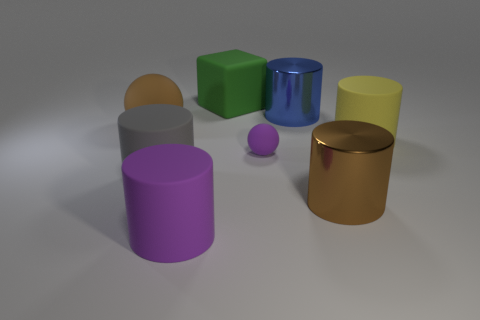Is there any other thing that is the same shape as the big green matte thing?
Ensure brevity in your answer.  No. How many big yellow cylinders are the same material as the green thing?
Your answer should be compact. 1. There is a block that is the same material as the large sphere; what is its color?
Keep it short and to the point. Green. Does the big gray matte thing have the same shape as the large blue thing?
Your response must be concise. Yes. There is a purple thing that is in front of the brown thing that is in front of the brown rubber sphere; is there a large cylinder that is on the right side of it?
Provide a succinct answer. Yes. How many big blocks have the same color as the tiny matte ball?
Your answer should be very brief. 0. What is the shape of the green thing that is the same size as the brown matte thing?
Your answer should be compact. Cube. There is a big ball; are there any big brown things in front of it?
Offer a terse response. Yes. Does the brown ball have the same size as the purple ball?
Ensure brevity in your answer.  No. What shape is the large metal object in front of the yellow thing?
Your answer should be compact. Cylinder. 